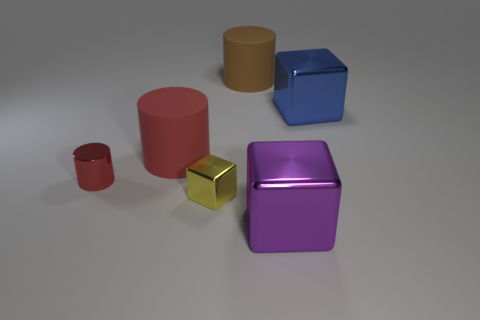How many things are big shiny cubes that are in front of the big blue block or small yellow balls?
Provide a succinct answer. 1. There is a metal object that is both behind the small block and left of the brown object; what is its size?
Offer a very short reply. Small. The other rubber cylinder that is the same color as the small cylinder is what size?
Provide a short and direct response. Large. How many other objects are there of the same size as the brown cylinder?
Give a very brief answer. 3. There is a big matte cylinder behind the big metallic cube that is to the right of the big shiny object in front of the small red shiny object; what color is it?
Your answer should be very brief. Brown. What is the shape of the shiny object that is right of the red matte object and on the left side of the big purple object?
Ensure brevity in your answer.  Cube. How many other objects are the same shape as the big brown object?
Give a very brief answer. 2. What is the shape of the small thing that is to the right of the big rubber cylinder that is on the left side of the matte object right of the big red rubber cylinder?
Your response must be concise. Cube. What number of things are either big green rubber things or purple metal things that are in front of the red metallic thing?
Offer a terse response. 1. Is the shape of the tiny object in front of the tiny metal cylinder the same as the purple metal thing on the right side of the large brown object?
Keep it short and to the point. Yes. 